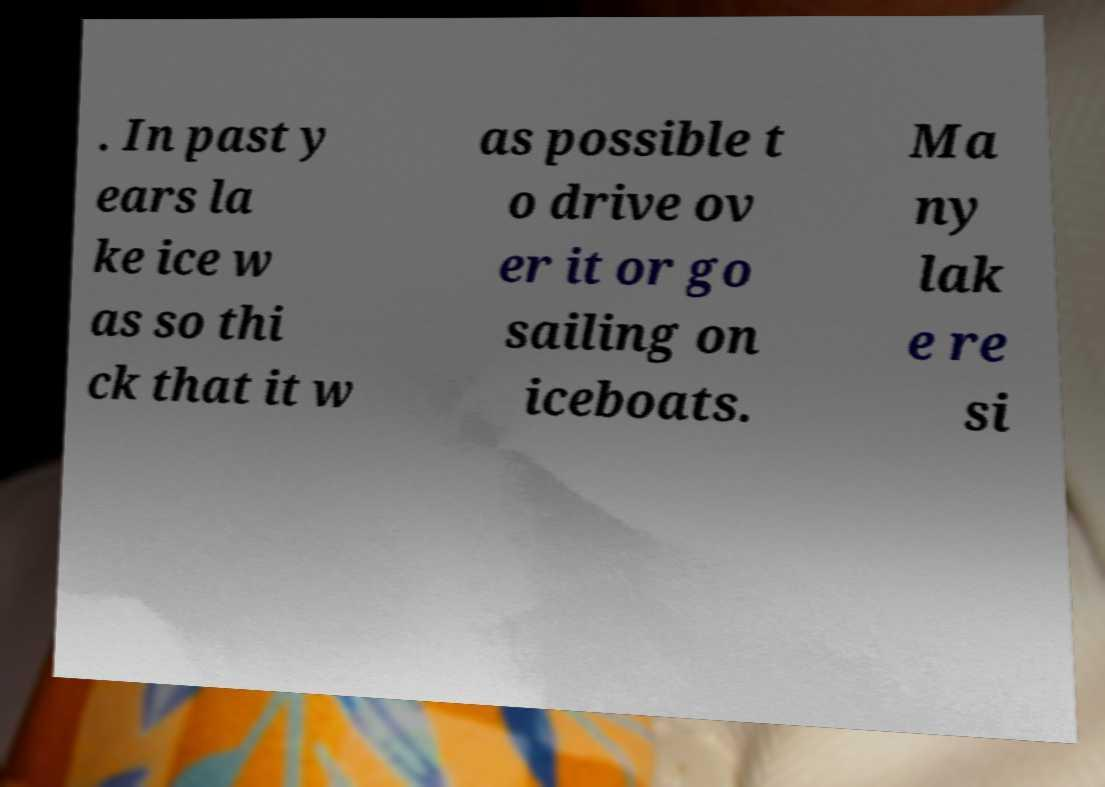Please read and relay the text visible in this image. What does it say? . In past y ears la ke ice w as so thi ck that it w as possible t o drive ov er it or go sailing on iceboats. Ma ny lak e re si 